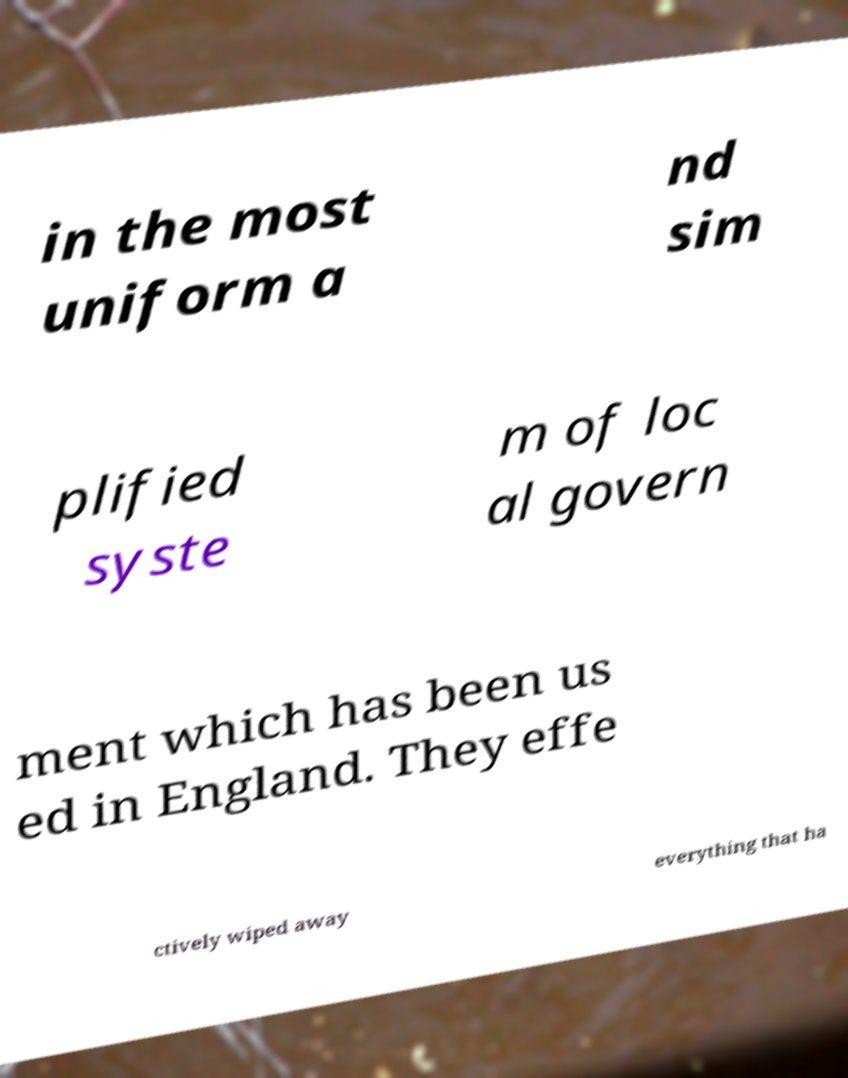Could you extract and type out the text from this image? in the most uniform a nd sim plified syste m of loc al govern ment which has been us ed in England. They effe ctively wiped away everything that ha 